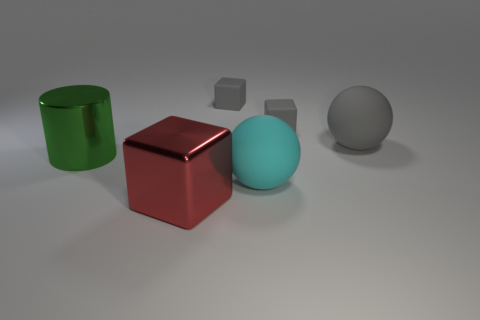If this image were for a product advertisement, what do you think it might be showcasing? If this image were used in a product advertisement, it could be showcasing a line of designer homeware or decorative items, emphasizing the sleek and modern aesthetic through the play of geometrical shapes and reflective materials. 